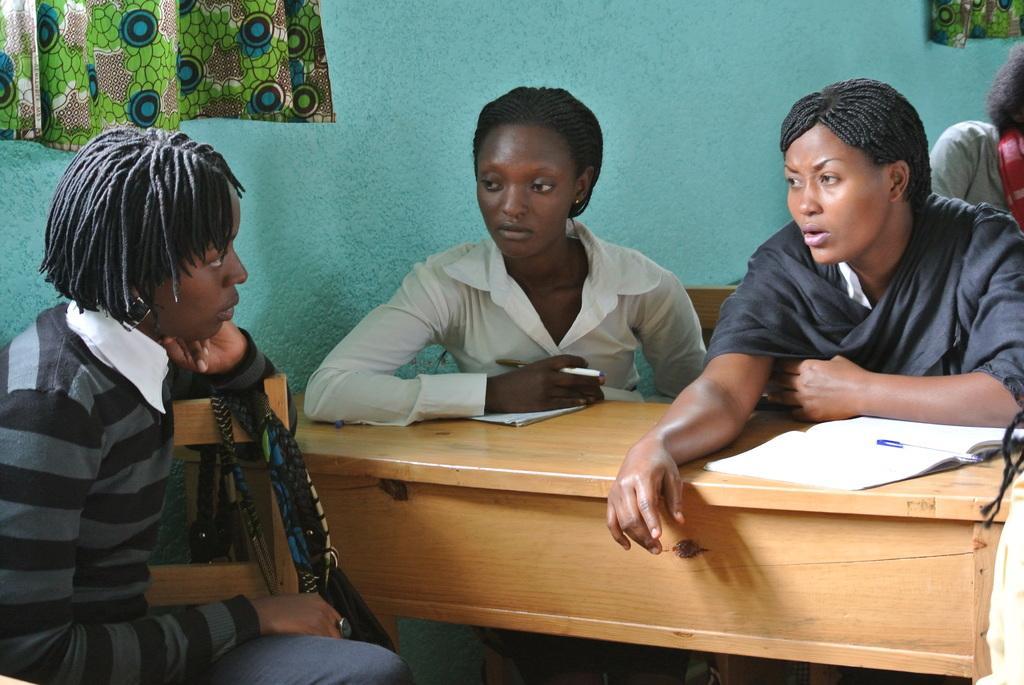How would you summarize this image in a sentence or two? In this picture we can see persons sitting on chairs near to the table and on the table we can see books, pen. On the background of the picture we can see wall, curtains. 